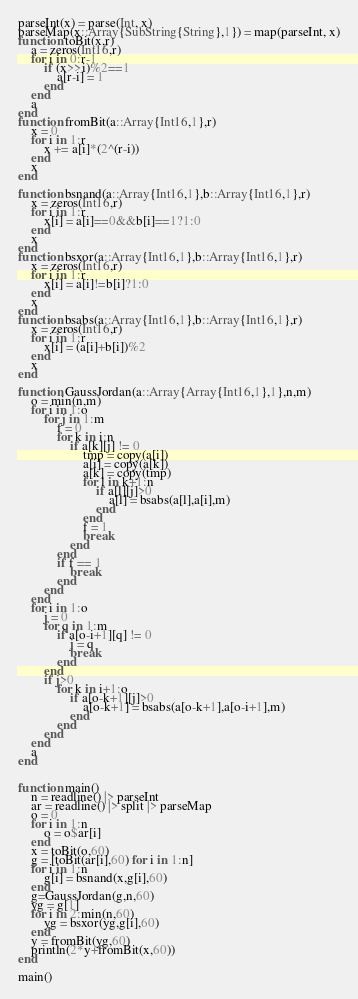<code> <loc_0><loc_0><loc_500><loc_500><_Julia_>parseInt(x) = parse(Int, x)
parseMap(x::Array{SubString{String},1}) = map(parseInt, x)
function toBit(x,r)
	a = zeros(Int16,r)
	for i in 0:r-1
		if (x>>i)%2==1
			a[r-i] = 1
		end
	end
	a
end
function fromBit(a::Array{Int16,1},r)
	x = 0
	for i in 1:r
		x += a[i]*(2^(r-i))
	end
	x
end

function bsnand(a::Array{Int16,1},b::Array{Int16,1},r)
	x = zeros(Int16,r)
	for i in 1:r
		x[i] = a[i]==0&&b[i]==1?1:0
	end
	x
end
function bsxor(a::Array{Int16,1},b::Array{Int16,1},r)
	x = zeros(Int16,r)
	for i in 1:r
		x[i] = a[i]!=b[i]?1:0
	end
	x
end
function bsabs(a::Array{Int16,1},b::Array{Int16,1},r)
	x = zeros(Int16,r)
	for i in 1:r
		x[i] = (a[i]+b[i])%2
	end
	x
end

function GaussJordan(a::Array{Array{Int16,1},1},n,m)
	o = min(n,m)
	for i in 1:o
		for j in 1:m
			f = 0
			for k in i:n
				if a[k][j] != 0
					tmp = copy(a[i])
					a[i] = copy(a[k])
					a[k] = copy(tmp)
					for l in k+1:n
						if a[l][j]>0
							a[l] = bsabs(a[l],a[i],m)
						end
					end
					f = 1
					break
				end
			end
			if f == 1
				break
			end
		end
	end
	for i in 1:o
		j = 0
		for q in 1:m
			if a[o-i+1][q] != 0
				j = q
				break
			end
		end
		if j>0
			for k in i+1:o
				if a[o-k+1][j]>0
					a[o-k+1] = bsabs(a[o-k+1],a[o-i+1],m)
				end
			end
		end
	end
	a
end


function main()
	n = readline() |> parseInt
	ar = readline() |> split |> parseMap
	o = 0
	for i in 1:n
		o = o$ar[i]
	end
	x = toBit(o,60)
	g = [toBit(ar[i],60) for i in 1:n]
	for i in 1:n
		g[i] = bsnand(x,g[i],60)
	end
	g=GaussJordan(g,n,60)
	yg = g[1]
	for i in 2:min(n,60)
		yg = bsxor(yg,g[i],60)
	end
	y = fromBit(yg,60)
	println(2*y+fromBit(x,60))
end

main()</code> 